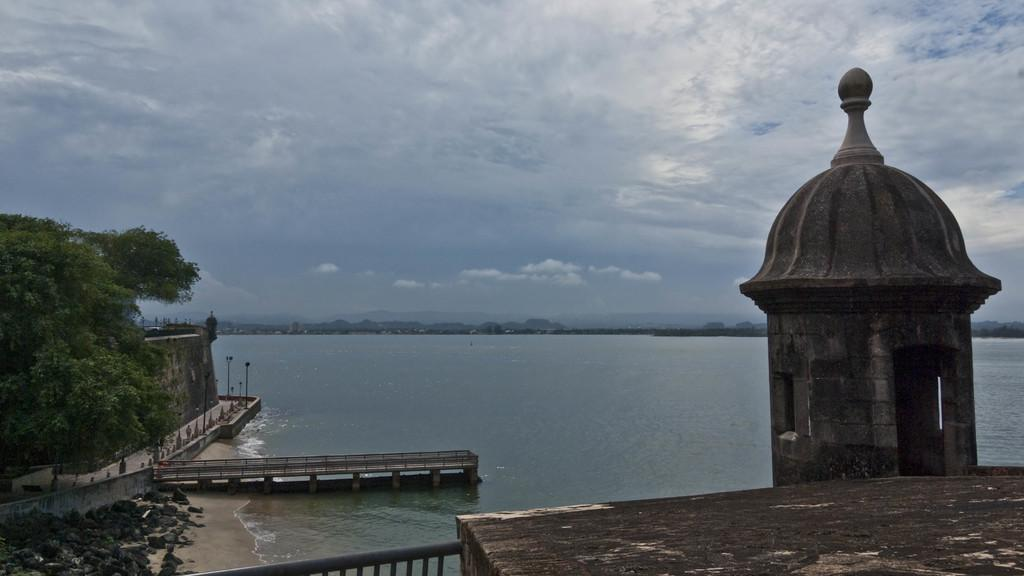What type of natural feature is visible in the image? There is a sea in the image. What man-made structure can be seen in the image? There is a monument in the image. What type of plant is present in the image? There is a tree in the image. What type of landscape feature is visible in the image? There are hills in the image. What type of produce is being harvested in the image? There is no produce or harvesting activity present in the image. What type of fork is being used to eat the seafood in the image? There is no seafood or fork present in the image. 